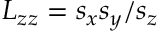<formula> <loc_0><loc_0><loc_500><loc_500>L _ { z z } = s _ { x } s _ { y } / s _ { z }</formula> 